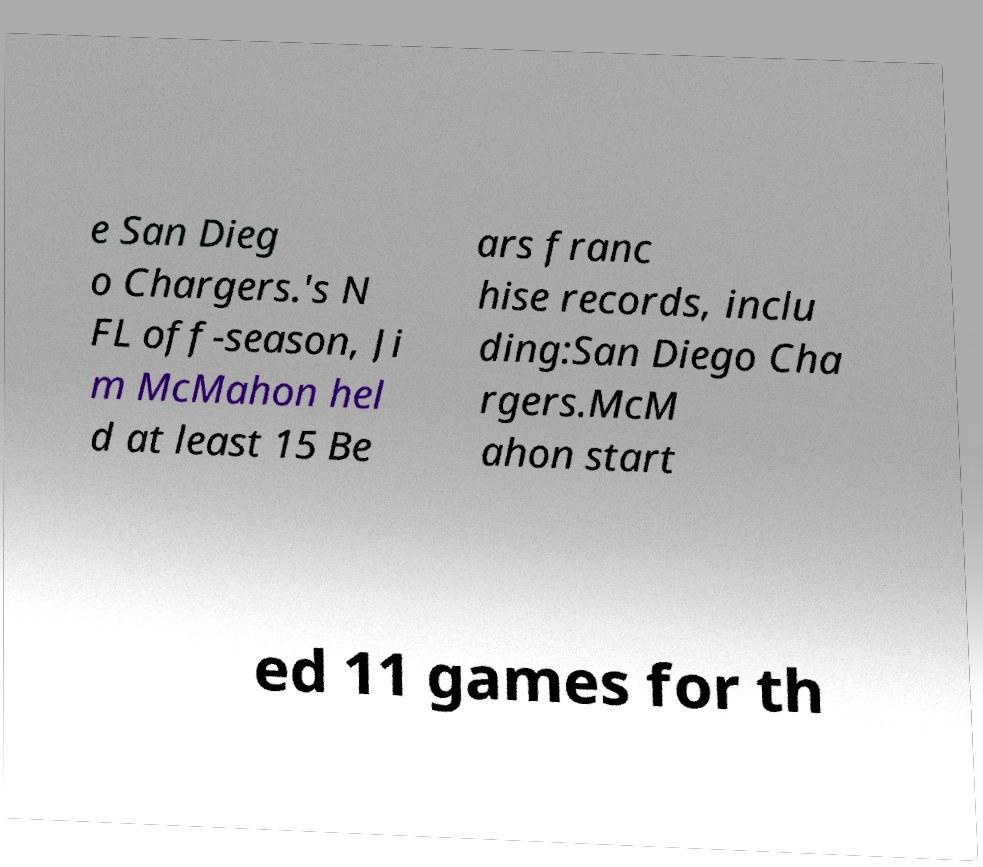Please read and relay the text visible in this image. What does it say? e San Dieg o Chargers.'s N FL off-season, Ji m McMahon hel d at least 15 Be ars franc hise records, inclu ding:San Diego Cha rgers.McM ahon start ed 11 games for th 